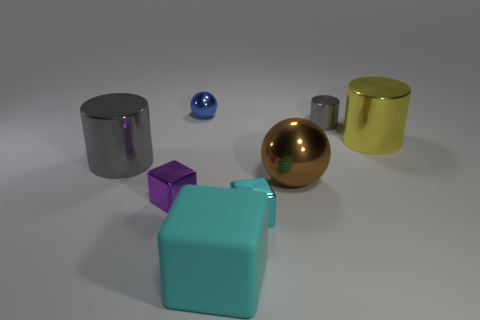There is a large thing that is the same shape as the tiny blue thing; what material is it? metal 